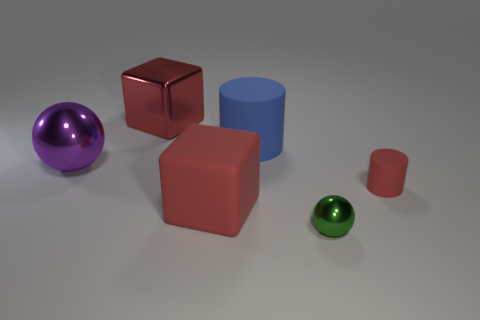Does the red thing that is on the right side of the large cylinder have the same size as the cube to the right of the big red shiny thing? While both objects exhibit a cubical shape, after closer inspection, the red object on the right side of the large cylinder appears to be slightly smaller in size than the shiny red cube to the right of it. 